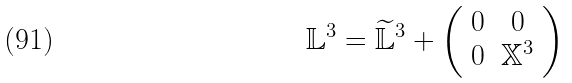<formula> <loc_0><loc_0><loc_500><loc_500>\mathbb { L } ^ { 3 } = \widetilde { \mathbb { L } } ^ { 3 } + \left ( \begin{array} { c c } 0 & 0 \\ 0 & \mathbb { X } ^ { 3 } \end{array} \right )</formula> 